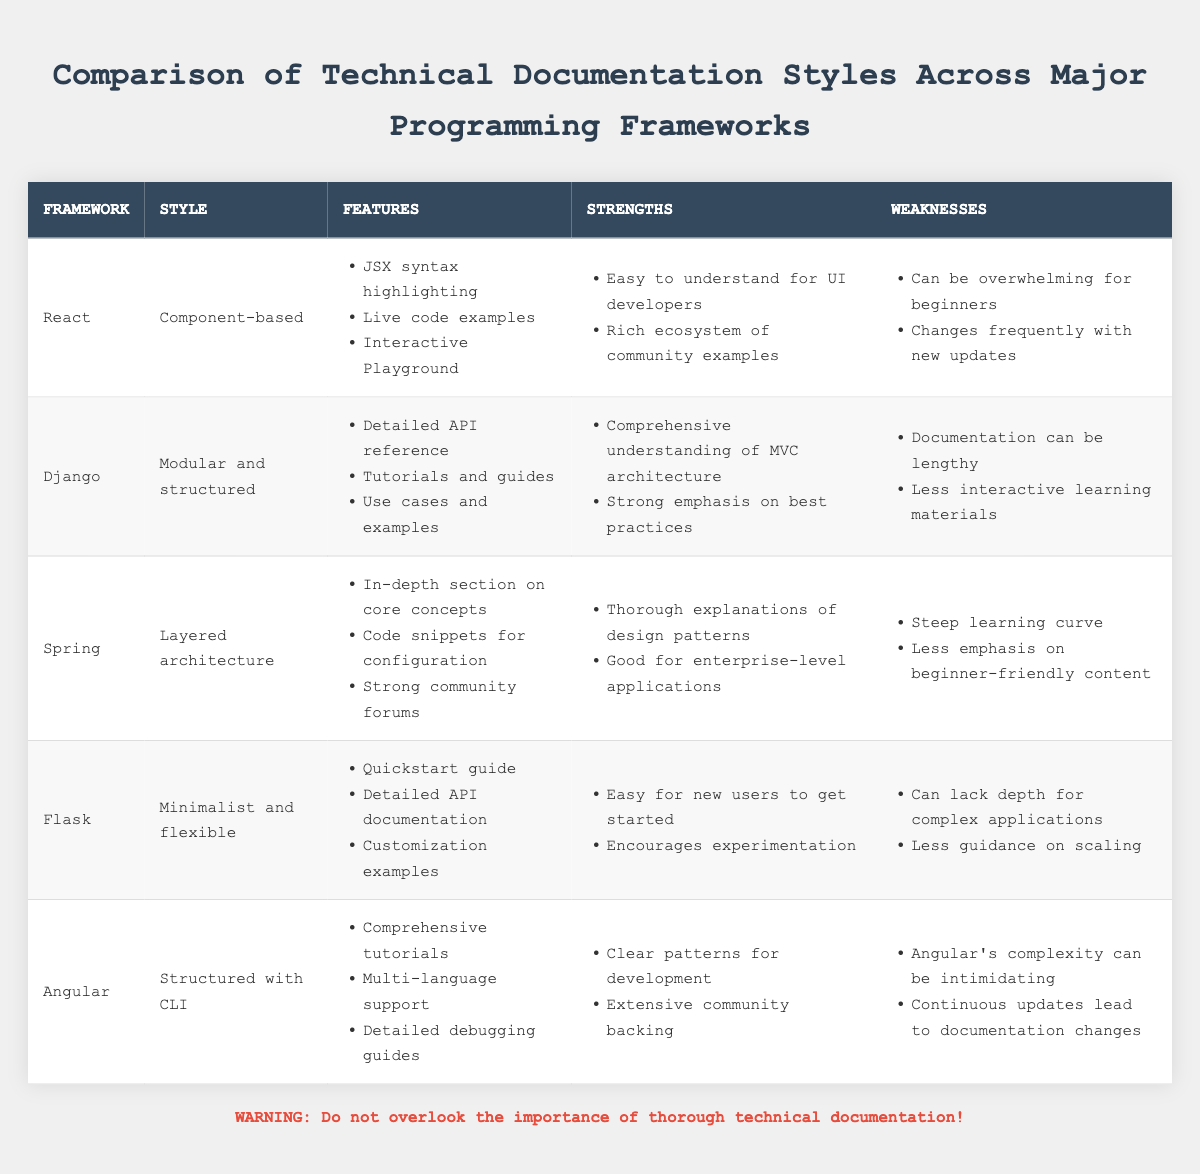What documentation style is used by Flask? According to the table, Flask employs a "Minimalist and flexible" documentation style.
Answer: Minimalist and flexible Which framework has a style that emphasizes "structured with CLI"? The table shows that the "Angular" framework has a documentation style that is "Structured with CLI".
Answer: Angular How many strengths are listed for Django? From the table, Django lists two strengths: "Comprehensive understanding of MVC architecture" and "Strong emphasis on best practices." Thus, the count is two.
Answer: 2 Which framework has the fewest weaknesses? By reviewing the weaknesses listed in the table, Flask has two weaknesses: "Can lack depth for complex applications" and "Less guidance on scaling." Other frameworks have more than two. Therefore, Flask has the fewest weaknesses.
Answer: Flask Is there an interactive playground feature in the documentation of Angular? The table does not list an "Interactive Playground" feature for Angular; it is only mentioned under React. Therefore, the answer is no.
Answer: No Which framework documentation emphasizes the best practices? The table indicates that the Django framework has a strength focusing on "Strong emphasis on best practices." Hence, Django is correct.
Answer: Django What is the common strength across React and Flask? By analyzing the strengths listed for both frameworks, both React and Flask encourage user-friendliness: React is "Easy to understand for UI developers," and Flask is "Easy for new users to get started." Thus, the common theme is user-friendliness.
Answer: User-friendliness How would one summarize the depth of the documentation for Spring? The table mentions that Spring has a "Steep learning curve" and "Less emphasis on beginner-friendly content." This indicates that Spring is designed for more experienced users, suggesting it is not beginner-friendly.
Answer: Not beginner-friendly What is the total number of features listed for all frameworks? By counting the features from the table, React has 3, Django has 3, Spring has 3, Flask has 3, and Angular has 3, leading to the total: 3 + 3 + 3 + 3 + 3 = 15.
Answer: 15 